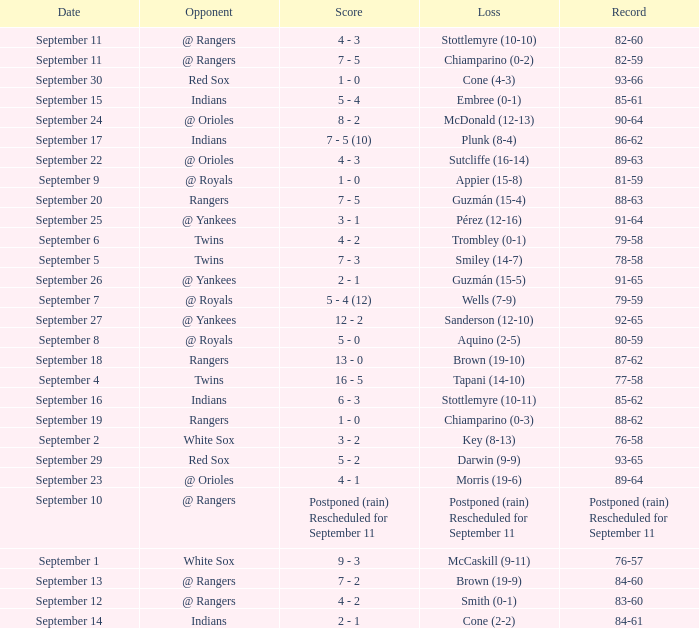Could you help me parse every detail presented in this table? {'header': ['Date', 'Opponent', 'Score', 'Loss', 'Record'], 'rows': [['September 11', '@ Rangers', '4 - 3', 'Stottlemyre (10-10)', '82-60'], ['September 11', '@ Rangers', '7 - 5', 'Chiamparino (0-2)', '82-59'], ['September 30', 'Red Sox', '1 - 0', 'Cone (4-3)', '93-66'], ['September 15', 'Indians', '5 - 4', 'Embree (0-1)', '85-61'], ['September 24', '@ Orioles', '8 - 2', 'McDonald (12-13)', '90-64'], ['September 17', 'Indians', '7 - 5 (10)', 'Plunk (8-4)', '86-62'], ['September 22', '@ Orioles', '4 - 3', 'Sutcliffe (16-14)', '89-63'], ['September 9', '@ Royals', '1 - 0', 'Appier (15-8)', '81-59'], ['September 20', 'Rangers', '7 - 5', 'Guzmán (15-4)', '88-63'], ['September 25', '@ Yankees', '3 - 1', 'Pérez (12-16)', '91-64'], ['September 6', 'Twins', '4 - 2', 'Trombley (0-1)', '79-58'], ['September 5', 'Twins', '7 - 3', 'Smiley (14-7)', '78-58'], ['September 26', '@ Yankees', '2 - 1', 'Guzmán (15-5)', '91-65'], ['September 7', '@ Royals', '5 - 4 (12)', 'Wells (7-9)', '79-59'], ['September 27', '@ Yankees', '12 - 2', 'Sanderson (12-10)', '92-65'], ['September 8', '@ Royals', '5 - 0', 'Aquino (2-5)', '80-59'], ['September 18', 'Rangers', '13 - 0', 'Brown (19-10)', '87-62'], ['September 4', 'Twins', '16 - 5', 'Tapani (14-10)', '77-58'], ['September 16', 'Indians', '6 - 3', 'Stottlemyre (10-11)', '85-62'], ['September 19', 'Rangers', '1 - 0', 'Chiamparino (0-3)', '88-62'], ['September 2', 'White Sox', '3 - 2', 'Key (8-13)', '76-58'], ['September 29', 'Red Sox', '5 - 2', 'Darwin (9-9)', '93-65'], ['September 23', '@ Orioles', '4 - 1', 'Morris (19-6)', '89-64'], ['September 10', '@ Rangers', 'Postponed (rain) Rescheduled for September 11', 'Postponed (rain) Rescheduled for September 11', 'Postponed (rain) Rescheduled for September 11'], ['September 1', 'White Sox', '9 - 3', 'McCaskill (9-11)', '76-57'], ['September 13', '@ Rangers', '7 - 2', 'Brown (19-9)', '84-60'], ['September 12', '@ Rangers', '4 - 2', 'Smith (0-1)', '83-60'], ['September 14', 'Indians', '2 - 1', 'Cone (2-2)', '84-61']]} What opponent has a record of 86-62? Indians. 